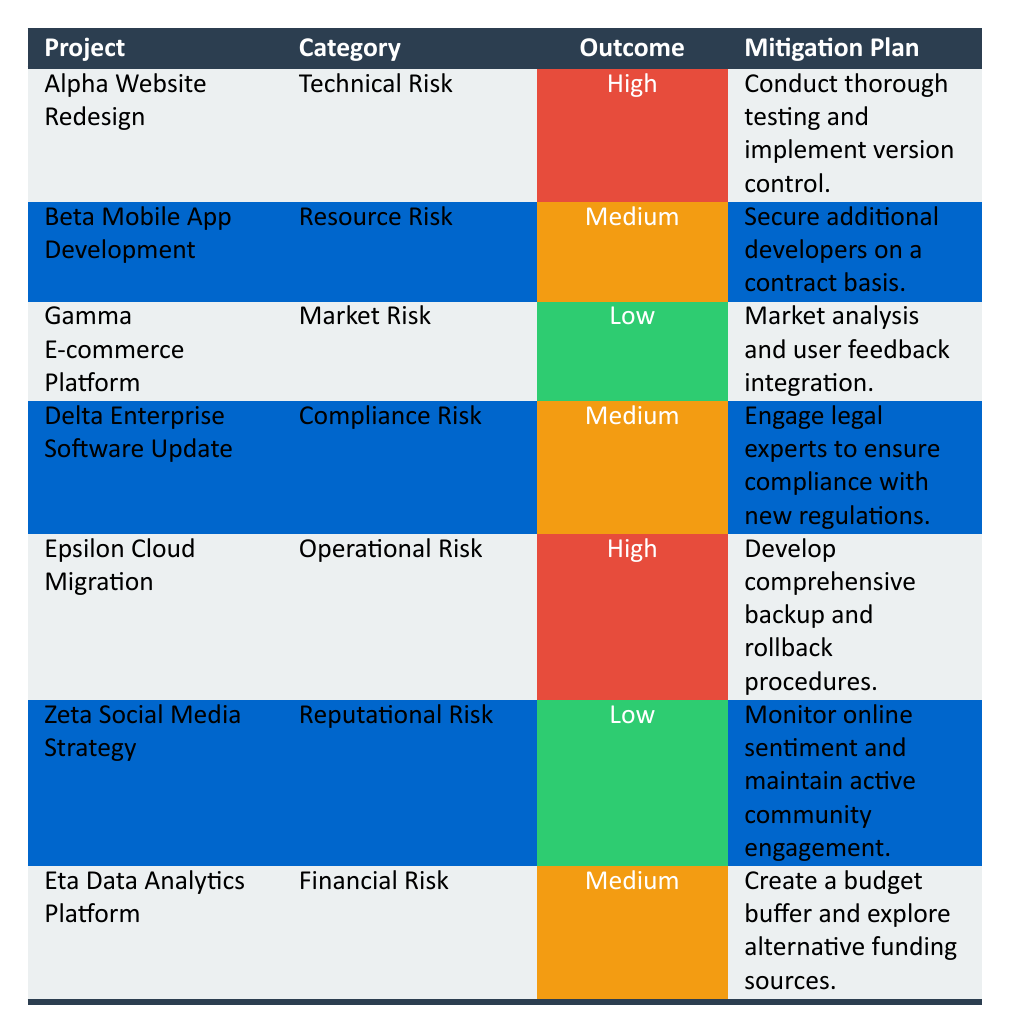What is the outcome of the Alpha Website Redesign project? The table lists the projects and their outcomes. For the Alpha Website Redesign, the specified outcome is "High."
Answer: High Which project has a "Medium" outcome under Compliance Risk? By scanning the table, the project listed under Compliance Risk with a "Medium" outcome is the Delta Enterprise Software Update.
Answer: Delta Enterprise Software Update Is there any project with a "Low" outcome in the Reputational Risk category? The table lists Zeta Social Media Strategy under Reputational Risk, and its outcome is categorized as "Low." Thus, the statement is true.
Answer: Yes How many projects have a "High" outcome? The table shows two projects with a "High" outcome: Alpha Website Redesign and Epsilon Cloud Migration. Therefore, the total count of projects with a "High" outcome is 2.
Answer: 2 What is the mitigation plan for projects with a "Medium" outcome? The projects with "Medium" outcomes are Beta Mobile App Development and Delta Enterprise Software Update. Their mitigation plans are: "Secure additional developers on a contract basis" and "Engage legal experts to ensure compliance with new regulations," respectively.
Answer: Secure additional developers; Engage legal experts Which project falls under Operational Risk and what is its outcome? Looking at the table, Epsilon Cloud Migration is identified as the project under Operational Risk, and it has a "High" outcome.
Answer: Epsilon Cloud Migration, High Is the Gamma E-commerce Platform project experiencing a Medium outcome? The table specifies that the Gamma E-commerce Platform has a "Low" outcome, which indicates that the statement is false.
Answer: No Which project combines both Technical Risk and a High outcome? Scanning the table reveals that only the Alpha Website Redesign project is categorized under Technical Risk with a "High" outcome. Therefore, it fulfills the criteria of the question.
Answer: Alpha Website Redesign 